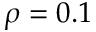<formula> <loc_0><loc_0><loc_500><loc_500>\rho = 0 . 1</formula> 